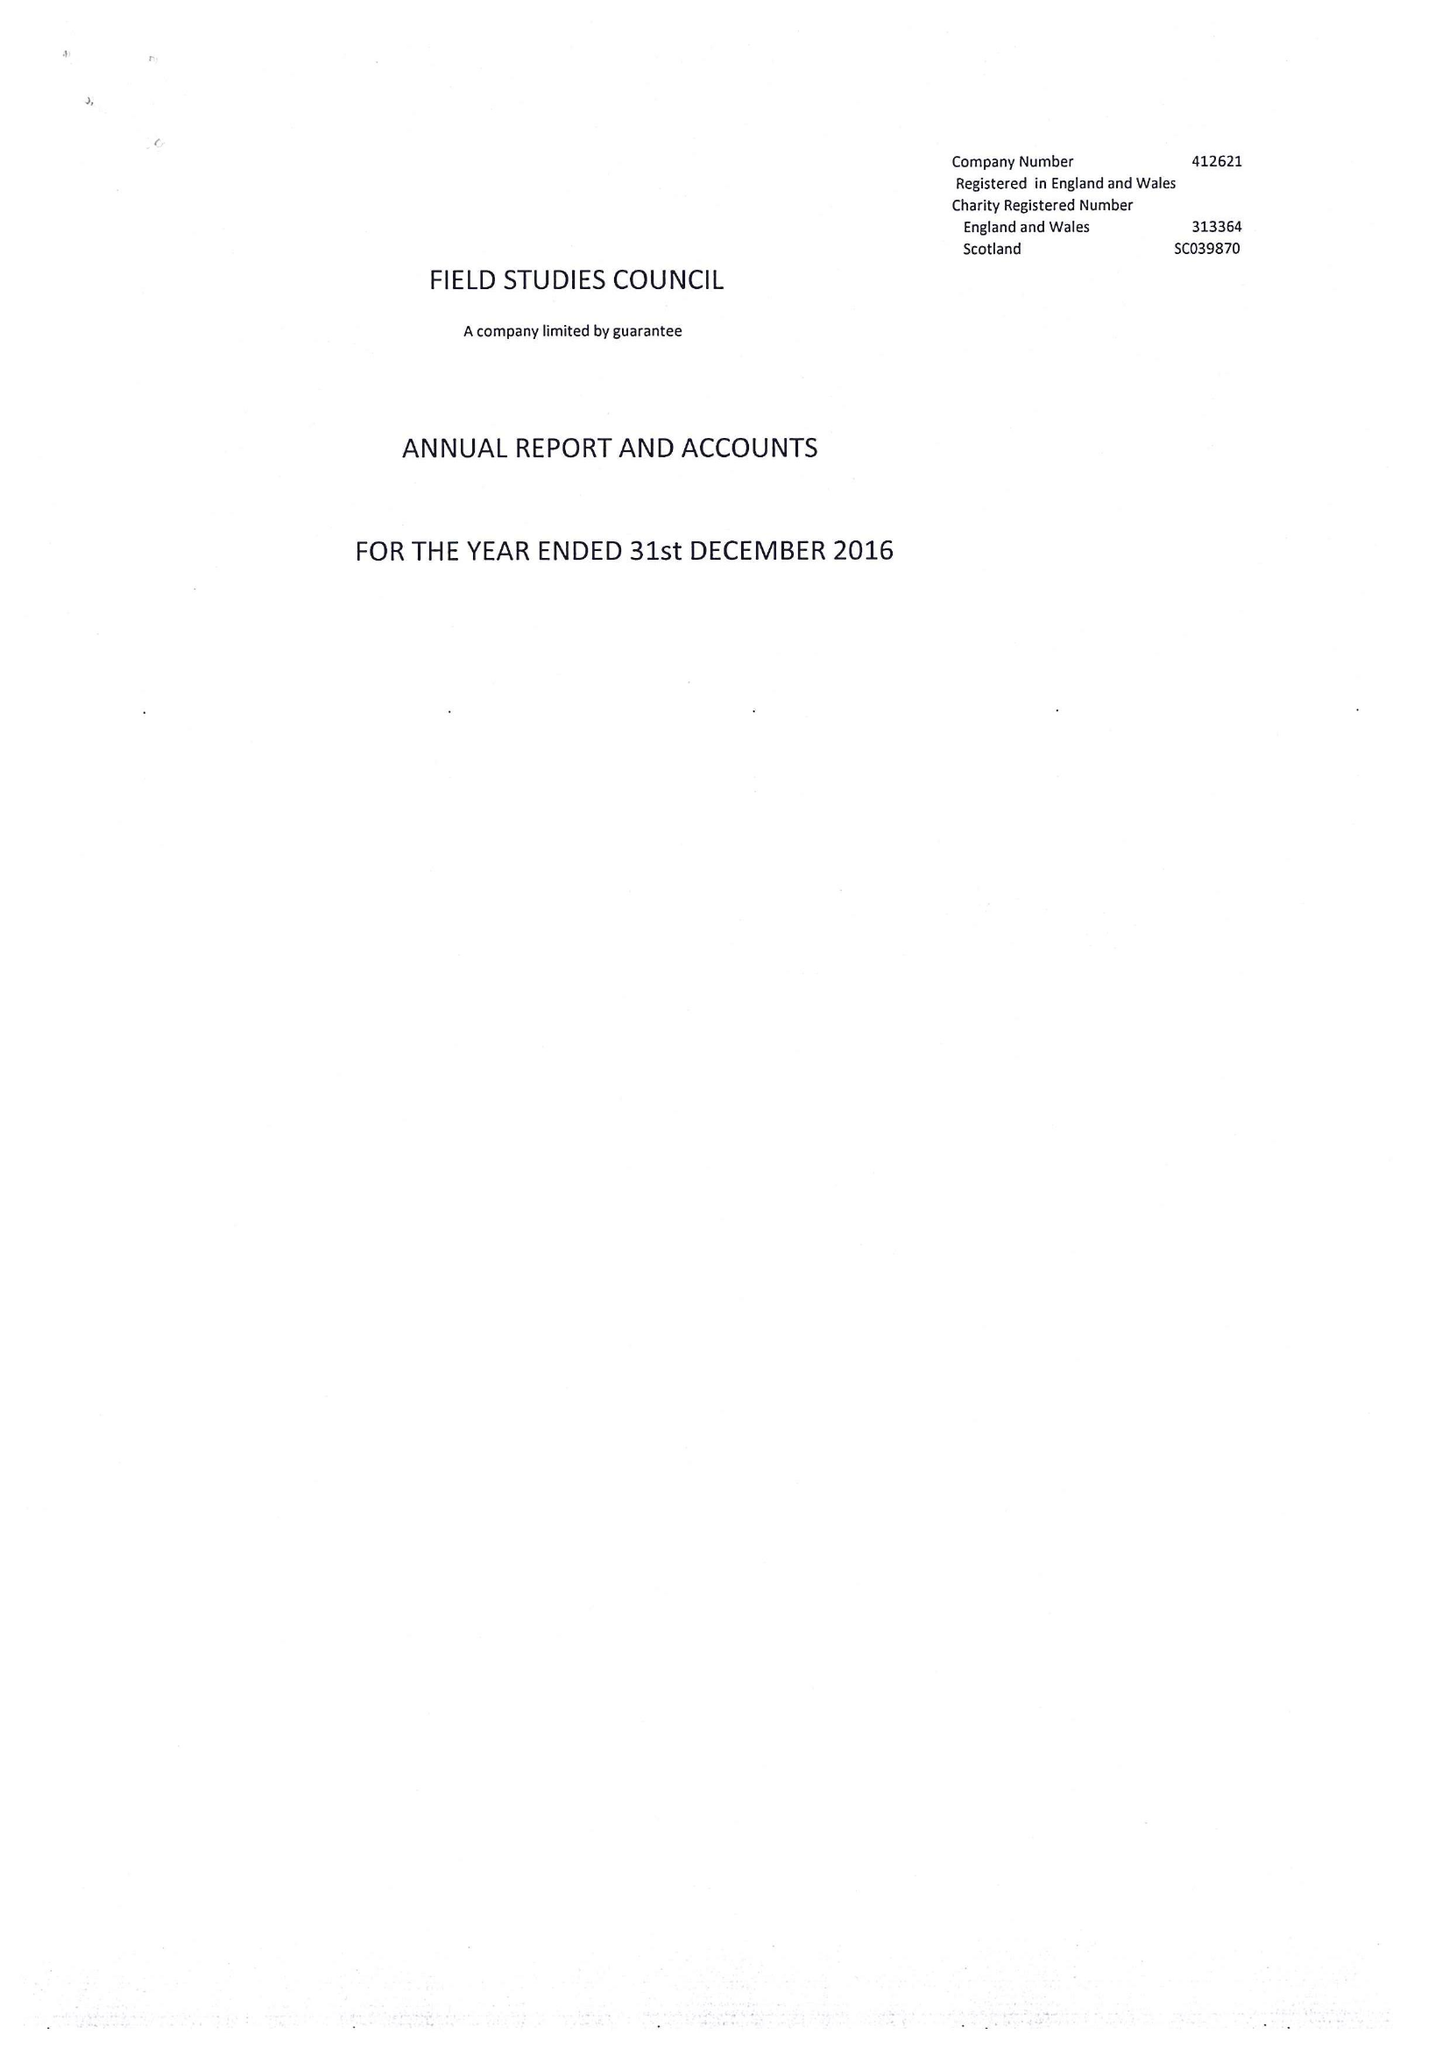What is the value for the address__post_town?
Answer the question using a single word or phrase. SHREWSBURY 